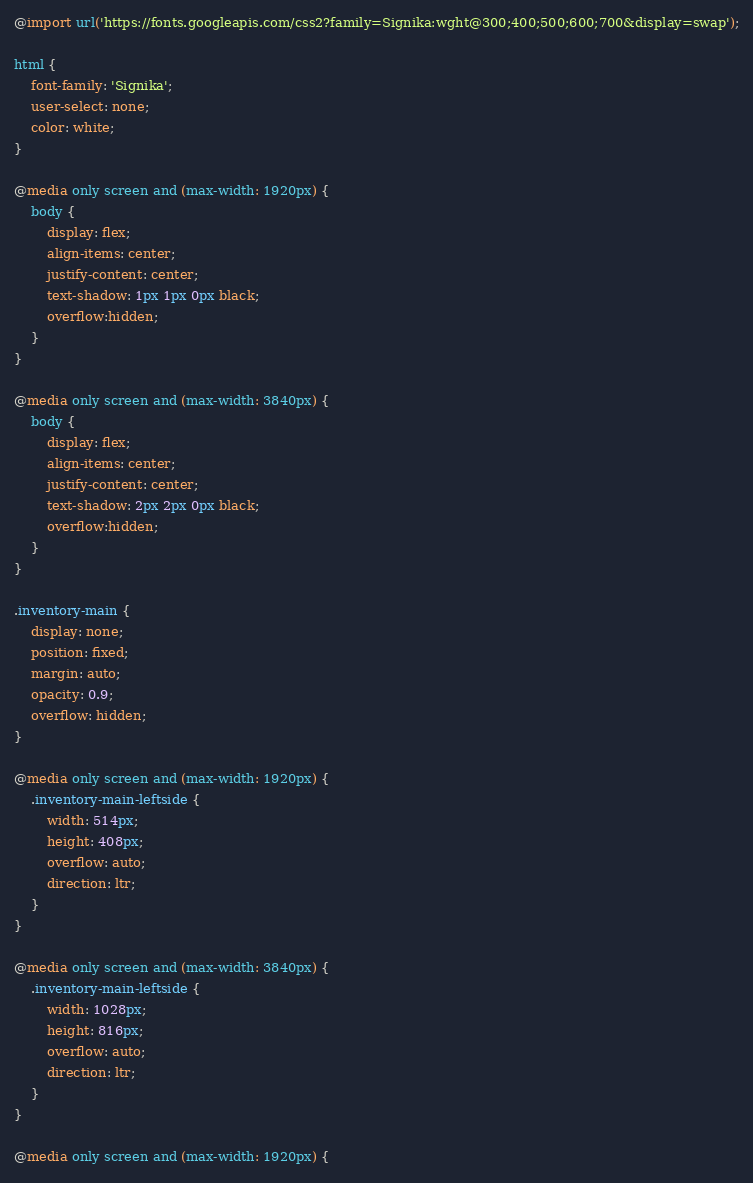Convert code to text. <code><loc_0><loc_0><loc_500><loc_500><_CSS_>@import url('https://fonts.googleapis.com/css2?family=Signika:wght@300;400;500;600;700&display=swap');

html {
	font-family: 'Signika';
	user-select: none;
	color: white;
}

@media only screen and (max-width: 1920px) {
	body {
		display: flex;
		align-items: center;
		justify-content: center;
		text-shadow: 1px 1px 0px black;
		overflow:hidden;
	}
}

@media only screen and (max-width: 3840px) {
	body {
		display: flex;
		align-items: center;
		justify-content: center;
		text-shadow: 2px 2px 0px black;
		overflow:hidden;
	}
}

.inventory-main {
	display: none;
	position: fixed;
	margin: auto;
	opacity: 0.9;
	overflow: hidden;
}

@media only screen and (max-width: 1920px) {
	.inventory-main-leftside {
		width: 514px;
		height: 408px;
		overflow: auto;
		direction: ltr;
	}
}

@media only screen and (max-width: 3840px) {
	.inventory-main-leftside {
		width: 1028px;
		height: 816px;
		overflow: auto;
		direction: ltr;
	}
}

@media only screen and (max-width: 1920px) {</code> 